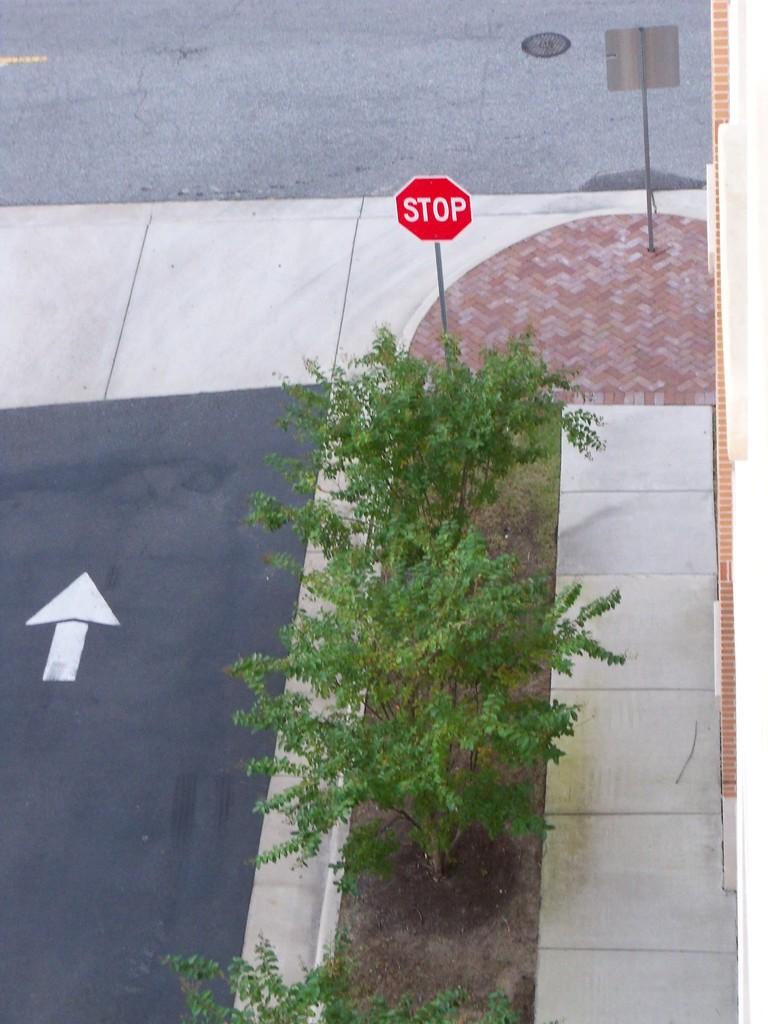What does the sign say?
Ensure brevity in your answer.  Stop. 